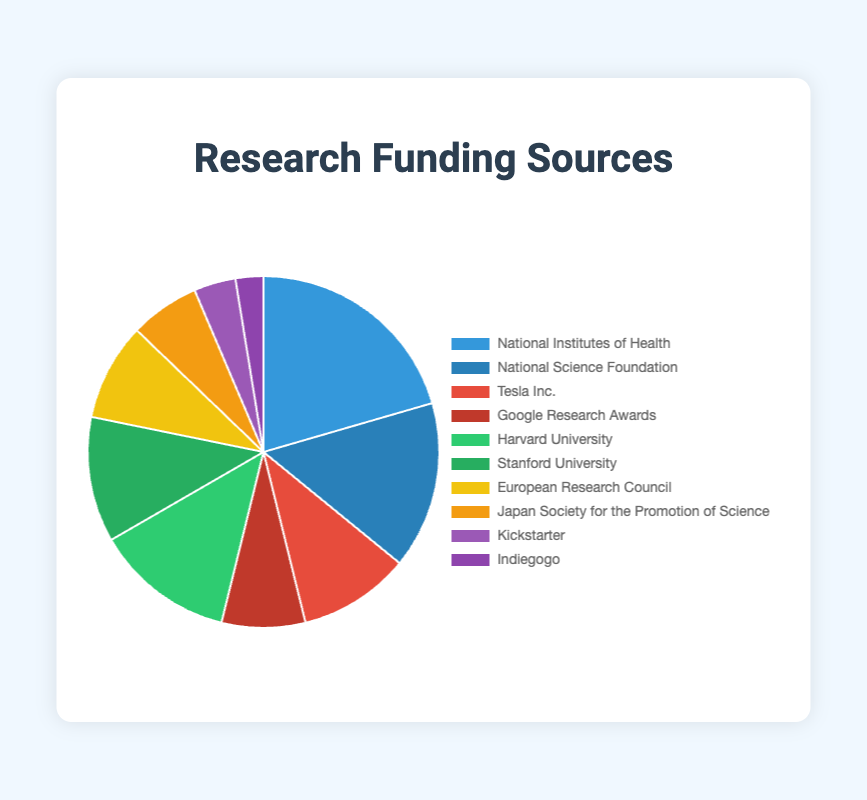Which funding source received the largest amount? The pie chart shows the segments by funding amount, and the largest segment corresponds to the National Institutes of Health with $800,000.
Answer: National Institutes of Health Which type of funding contributes the most to the overall funding? Summing the amounts from each funding type: Government Grants ($800,000 + $600,000), Private Sector Grants ($400,000 + $300,000), University Funds ($500,000 + $450,000), International Funds ($350,000 + $250,000), Crowdfunding ($150,000 + $100,000), Government Grants have the highest total funding.
Answer: Government Grants Are contributions from University Funds greater than Private Sector Grants? Adding University Funds (Harvard University: $500,000 + Stanford University: $450,000) gives $950,000. Adding Private Sector Grants (Tesla Inc.: $400,000 + Google Research Awards: $300,000) gives $700,000. $950,000 is greater than $700,000.
Answer: Yes What percentage of the total funding is from Crowdfunding sources? Total funding: $800,000 + $600,000 + $400,000 + $300,000 + $500,000 + $450,000 + $350,000 + $250,000 + $150,000 + $100,000 = $3,900,000. Crowdfunding total: $150,000 + $100,000 = $250,000. Percent: ($250,000 / $3,900,000) * 100 = 6.41%
Answer: 6.41% Compare funding from the European Research Council and the Japan Society for the Promotion of Science. Which is higher? The funding amount for the European Research Council is $350,000, and for the Japan Society for the Promotion of Science is $250,000. $350,000 is higher than $250,000.
Answer: European Research Council What is the combined funding amount from the National Institutes of Health and the National Science Foundation? Adding National Institutes of Health: $800,000 and National Science Foundation: $600,000 results in a total of $800,000 + $600,000 = $1,400,000.
Answer: $1,400,000 Which sector has the smallest segment in the pie chart? Crowdfunding: Kickstarter ($150,000) and Indiegogo ($100,000) together sum up to $250,000, which is the smallest compared to other sectors.
Answer: Crowdfunding What is the total funding provided by all International Funds? Adding European Research Council: $350,000 and Japan Society for the Promotion of Science: $250,000 results in $350,000 + $250,000 = $600,000.
Answer: $600,000 